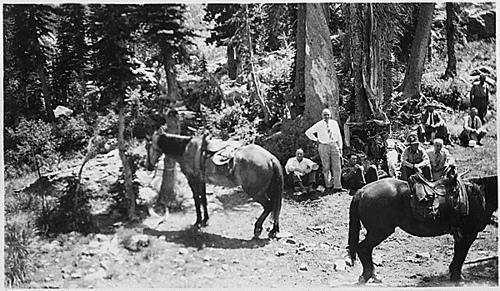How many men are standing up?
Give a very brief answer. 1. How many horses can be seen?
Give a very brief answer. 2. 